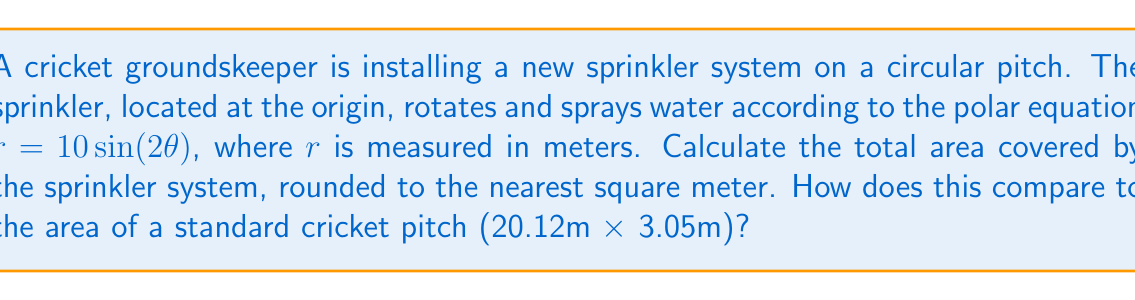Show me your answer to this math problem. To solve this problem, we'll follow these steps:

1) The area covered by a polar curve is given by the formula:

   $$A = \frac{1}{2}\int_{0}^{2\pi} r^2 d\theta$$

2) In this case, $r = 10\sin(2\theta)$. We need to square this:

   $$r^2 = 100\sin^2(2\theta)$$

3) Now we can set up our integral:

   $$A = \frac{1}{2}\int_{0}^{2\pi} 100\sin^2(2\theta) d\theta$$

4) To evaluate this, we can use the trigonometric identity:

   $$\sin^2(2\theta) = \frac{1}{2}(1 - \cos(4\theta))$$

5) Substituting this in:

   $$A = \frac{1}{2}\int_{0}^{2\pi} 100 \cdot \frac{1}{2}(1 - \cos(4\theta)) d\theta$$
   $$= 25\int_{0}^{2\pi} (1 - \cos(4\theta)) d\theta$$

6) Evaluating the integral:

   $$A = 25[\theta - \frac{1}{4}\sin(4\theta)]_{0}^{2\pi}$$
   $$= 25[2\pi - 0 - (0 - 0)]$$
   $$= 50\pi$$

7) This gives us the area in square meters. Rounding to the nearest whole number:

   $$A \approx 157 \text{ m}^2$$

8) The area of a standard cricket pitch is:

   $$20.12\text{ m} \times 3.05\text{ m} = 61.366 \text{ m}^2$$

9) Comparing the two areas:

   $$\frac{157}{61.366} \approx 2.56$$

Therefore, the sprinkler system covers an area approximately 2.56 times larger than a standard cricket pitch.

[asy]
import graph;
size(200);
real r(real t) {return 10*sin(2*t);}
path g=polargraph(r,0,2*pi,operator ..);
draw(g,blue);
draw(circle((0,0),10),dashed);
label("$r=10\sin(2\theta)$",(7,7),NE);
[/asy]
Answer: The sprinkler system covers approximately 157 square meters, which is about 2.56 times the area of a standard cricket pitch. 